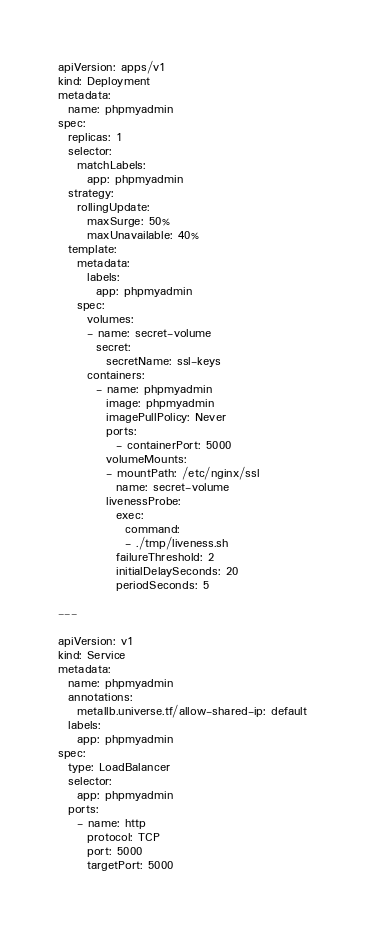<code> <loc_0><loc_0><loc_500><loc_500><_YAML_>apiVersion: apps/v1
kind: Deployment
metadata:
  name: phpmyadmin
spec:
  replicas: 1
  selector:
    matchLabels:
      app: phpmyadmin
  strategy:
    rollingUpdate:
      maxSurge: 50%
      maxUnavailable: 40%
  template:
    metadata:
      labels:
        app: phpmyadmin
    spec:
      volumes:
      - name: secret-volume
        secret:
          secretName: ssl-keys
      containers:
        - name: phpmyadmin
          image: phpmyadmin
          imagePullPolicy: Never
          ports:
            - containerPort: 5000
          volumeMounts:
          - mountPath: /etc/nginx/ssl
            name: secret-volume
          livenessProbe:
            exec:
              command:
              - ./tmp/liveness.sh
            failureThreshold: 2
            initialDelaySeconds: 20
            periodSeconds: 5

---

apiVersion: v1
kind: Service
metadata:
  name: phpmyadmin
  annotations:
    metallb.universe.tf/allow-shared-ip: default
  labels:
    app: phpmyadmin
spec:
  type: LoadBalancer
  selector:
    app: phpmyadmin
  ports:
    - name: http
      protocol: TCP
      port: 5000
      targetPort: 5000
</code> 